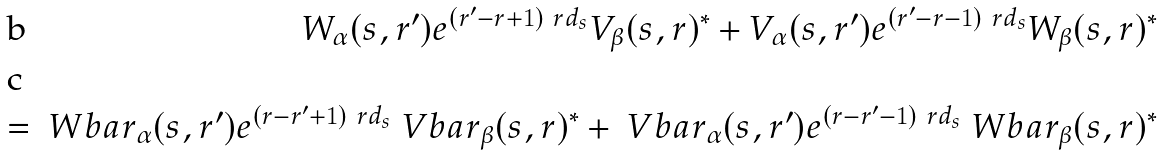<formula> <loc_0><loc_0><loc_500><loc_500>W _ { \alpha } ( s , r ^ { \prime } ) e ^ { ( r ^ { \prime } - r + 1 ) \ r d _ { s } } V _ { \beta } ( s , r ) ^ { * } + V _ { \alpha } ( s , r ^ { \prime } ) e ^ { ( r ^ { \prime } - r - 1 ) \ r d _ { s } } W _ { \beta } ( s , r ) ^ { * } \\ = \ W b a r _ { \alpha } ( s , r ^ { \prime } ) e ^ { ( r - r ^ { \prime } + 1 ) \ r d _ { s } } \ V b a r _ { \beta } ( s , r ) ^ { * } + \ V b a r _ { \alpha } ( s , r ^ { \prime } ) e ^ { ( r - r ^ { \prime } - 1 ) \ r d _ { s } } \ W b a r _ { \beta } ( s , r ) ^ { * }</formula> 